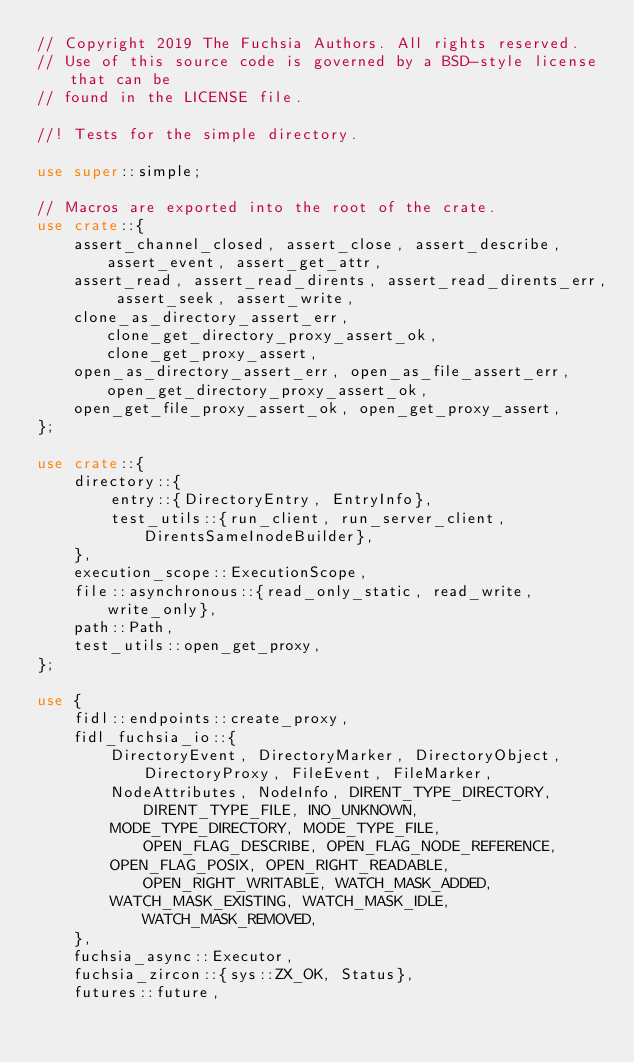Convert code to text. <code><loc_0><loc_0><loc_500><loc_500><_Rust_>// Copyright 2019 The Fuchsia Authors. All rights reserved.
// Use of this source code is governed by a BSD-style license that can be
// found in the LICENSE file.

//! Tests for the simple directory.

use super::simple;

// Macros are exported into the root of the crate.
use crate::{
    assert_channel_closed, assert_close, assert_describe, assert_event, assert_get_attr,
    assert_read, assert_read_dirents, assert_read_dirents_err, assert_seek, assert_write,
    clone_as_directory_assert_err, clone_get_directory_proxy_assert_ok, clone_get_proxy_assert,
    open_as_directory_assert_err, open_as_file_assert_err, open_get_directory_proxy_assert_ok,
    open_get_file_proxy_assert_ok, open_get_proxy_assert,
};

use crate::{
    directory::{
        entry::{DirectoryEntry, EntryInfo},
        test_utils::{run_client, run_server_client, DirentsSameInodeBuilder},
    },
    execution_scope::ExecutionScope,
    file::asynchronous::{read_only_static, read_write, write_only},
    path::Path,
    test_utils::open_get_proxy,
};

use {
    fidl::endpoints::create_proxy,
    fidl_fuchsia_io::{
        DirectoryEvent, DirectoryMarker, DirectoryObject, DirectoryProxy, FileEvent, FileMarker,
        NodeAttributes, NodeInfo, DIRENT_TYPE_DIRECTORY, DIRENT_TYPE_FILE, INO_UNKNOWN,
        MODE_TYPE_DIRECTORY, MODE_TYPE_FILE, OPEN_FLAG_DESCRIBE, OPEN_FLAG_NODE_REFERENCE,
        OPEN_FLAG_POSIX, OPEN_RIGHT_READABLE, OPEN_RIGHT_WRITABLE, WATCH_MASK_ADDED,
        WATCH_MASK_EXISTING, WATCH_MASK_IDLE, WATCH_MASK_REMOVED,
    },
    fuchsia_async::Executor,
    fuchsia_zircon::{sys::ZX_OK, Status},
    futures::future,</code> 